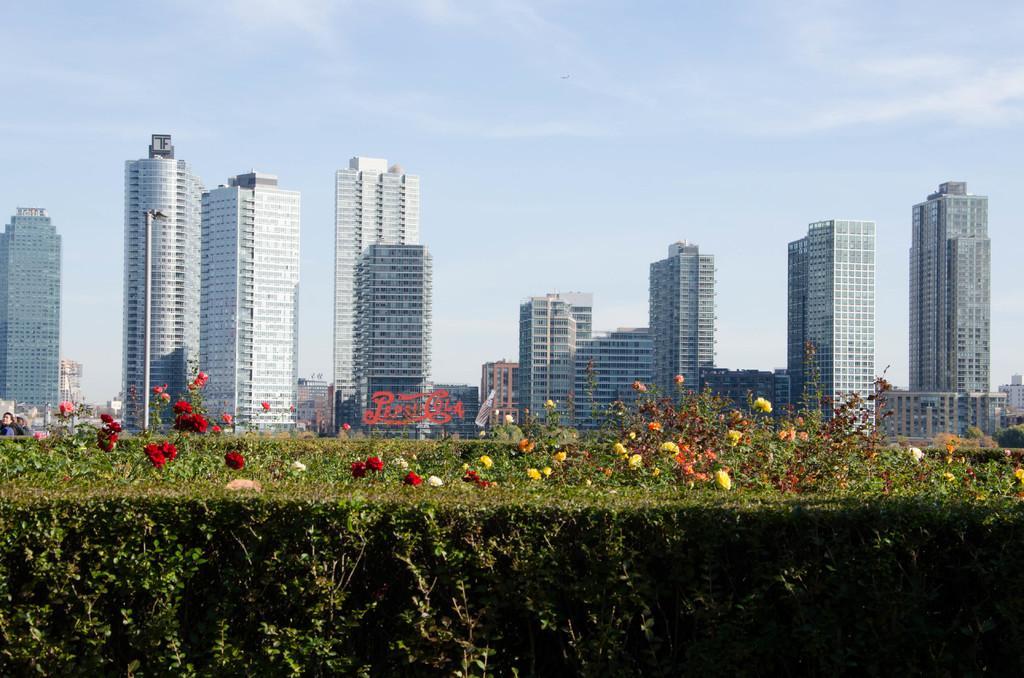Could you give a brief overview of what you see in this image? In this image I see the planets and I see flowers which are colorful. In the background I see number of buildings and I see the clear sky. 